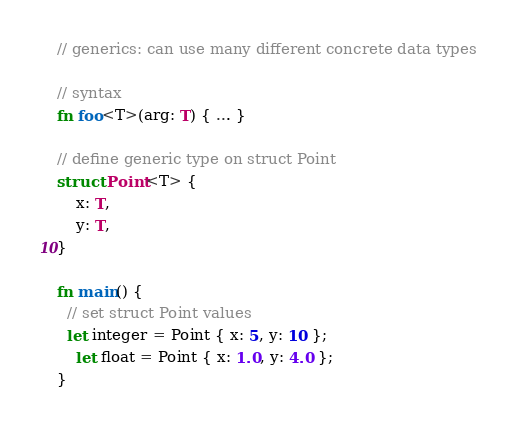<code> <loc_0><loc_0><loc_500><loc_500><_Rust_>// generics: can use many different concrete data types

// syntax
fn foo<T>(arg: T) { ... }

// define generic type on struct Point
struct Point<T> {
    x: T,
    y: T,
}

fn main() {
  // set struct Point values
  let integer = Point { x: 5, y: 10 };
    let float = Point { x: 1.0, y: 4.0 };
}</code> 